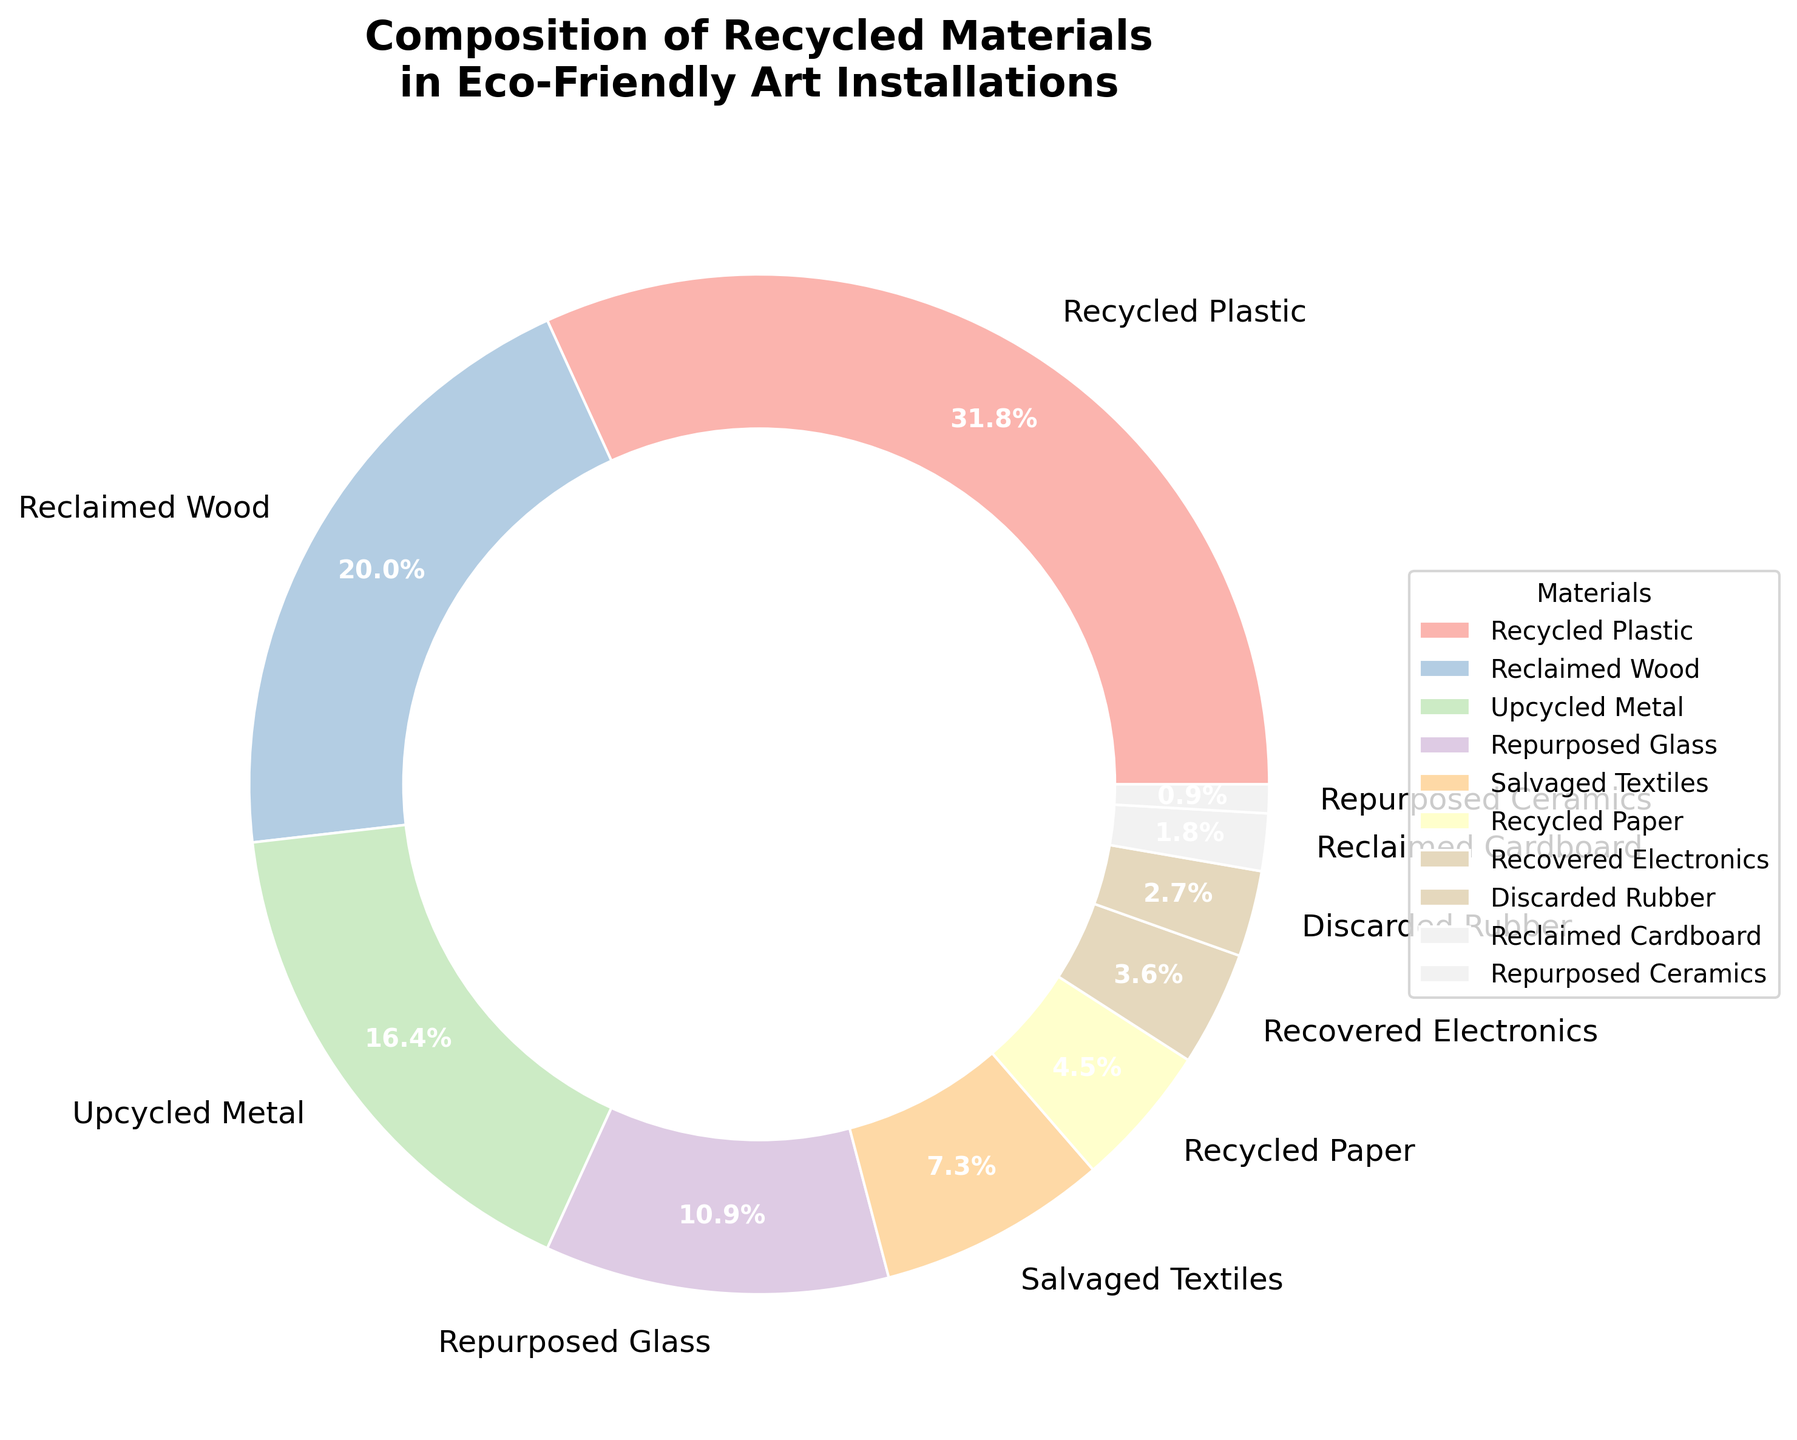Which material has the highest percentage? The pie chart indicates that "Recycled Plastic" occupies the largest section, explicitly showing 35%, which is the greatest percentage among all the materials.
Answer: Recycled Plastic How much greater is the percentage of "Recycled Plastic" compared to "Reclaimed Wood"? "Recycled Plastic" is shown to cover 35% of the materials, while "Reclaimed Wood" covers 22%. The difference between them is 35% - 22% = 13%.
Answer: 13% What is the combined percentage of "Upcycled Metal" and "Repurposed Glass"? "Upcycled Metal" encompasses 18% and "Repurposed Glass" encompasses 12%. Adding these percentages together: 18% + 12% = 30%.
Answer: 30% Which material has a lower percentage, "Salvaged Textiles" or "Recycled Paper"? By comparing the percentages shown in the pie chart, "Salvaged Textiles" has 8% and "Recycled Paper" has 5%. Since 5% < 8%, "Recycled Paper" has a lower percentage.
Answer: Recycled Paper What is the percentage difference between "Recovered Electronics" and "Discarded Rubber"? "Recovered Electronics" shows 4% while "Discarded Rubber" shows 3%. The difference is 4% - 3% = 1%.
Answer: 1% Which color wedge represents "Repurposed Ceramics"? The pie chart uses a custom color palette to differentiate materials. "Repurposed Ceramics" appears in the smallest wedge, which is colored in a distinct Pastel1 shade, but since exact colors are unavailable in textual format, let's note it as the smallest wedge.
Answer: Smallest Wedge How much more percentage is "Reclaimed Cardboard" than "Repurposed Ceramics"? "Reclaimed Cardboard" has 2%, while "Repurposed Ceramics" has 1%. The difference is 2% - 1% = 1%.
Answer: 1% What is the total percentage of all materials above 10%? The materials above 10% are "Recycled Plastic" (35%), "Reclaimed Wood" (22%), "Upcycled Metal" (18%), and "Repurposed Glass" (12%). The combined percentage is 35% + 22% + 18% + 12% = 87%.
Answer: 87% Which is more, the sum of "Salvaged Textiles", "Recycled Paper", and "Recovered Electronics", or "Upcycled Metal"? "Salvaged Textiles" is 8%, "Recycled Paper" is 5%, and "Recovered Electronics" is 4%. Their sum is 8% + 5% + 4% = 17%. "Upcycled Metal" is 18%. Comparing the two sums, 18% > 17%.
Answer: Upcycled Metal 